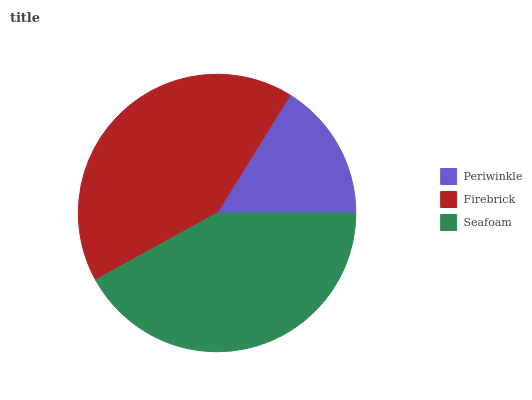Is Periwinkle the minimum?
Answer yes or no. Yes. Is Seafoam the maximum?
Answer yes or no. Yes. Is Firebrick the minimum?
Answer yes or no. No. Is Firebrick the maximum?
Answer yes or no. No. Is Firebrick greater than Periwinkle?
Answer yes or no. Yes. Is Periwinkle less than Firebrick?
Answer yes or no. Yes. Is Periwinkle greater than Firebrick?
Answer yes or no. No. Is Firebrick less than Periwinkle?
Answer yes or no. No. Is Firebrick the high median?
Answer yes or no. Yes. Is Firebrick the low median?
Answer yes or no. Yes. Is Periwinkle the high median?
Answer yes or no. No. Is Seafoam the low median?
Answer yes or no. No. 